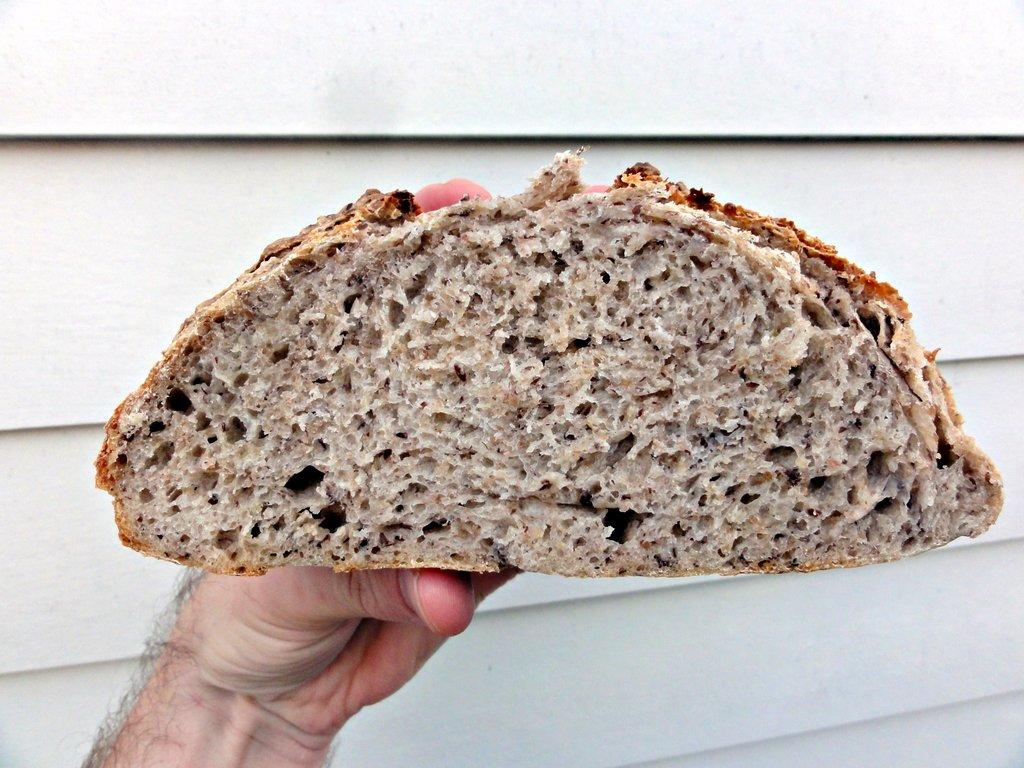What can be seen in the image related to a person's hand? There is a person's hand in the image. What is the person's hand holding? The person is holding a piece of bread. What type of desk can be seen in the foggy amusement park in the image? There is no desk, fog, or amusement park present in the image; it only features a person's hand holding a piece of bread. 